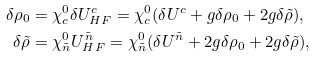<formula> <loc_0><loc_0><loc_500><loc_500>\delta \rho _ { 0 } & = \chi ^ { 0 } _ { c } \delta U ^ { c } _ { H F } = \chi ^ { 0 } _ { c } ( \delta U ^ { c } + g \delta \rho _ { 0 } + 2 g \delta \tilde { \rho } ) , \\ \delta \tilde { \rho } & = \chi ^ { 0 } _ { \tilde { n } } U ^ { \tilde { n } } _ { H F } = \chi ^ { 0 } _ { \tilde { n } } ( \delta U ^ { \tilde { n } } + 2 g \delta \rho _ { 0 } + 2 g \delta \tilde { \rho } ) ,</formula> 